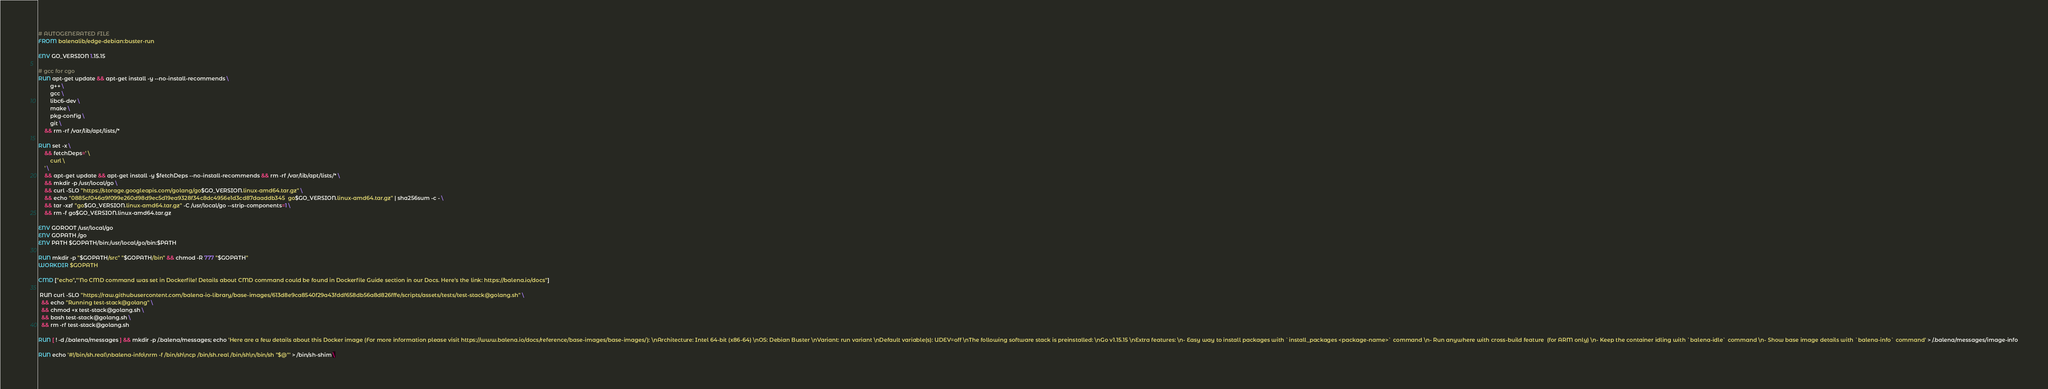<code> <loc_0><loc_0><loc_500><loc_500><_Dockerfile_># AUTOGENERATED FILE
FROM balenalib/edge-debian:buster-run

ENV GO_VERSION 1.15.15

# gcc for cgo
RUN apt-get update && apt-get install -y --no-install-recommends \
		g++ \
		gcc \
		libc6-dev \
		make \
		pkg-config \
		git \
	&& rm -rf /var/lib/apt/lists/*

RUN set -x \
	&& fetchDeps=' \
		curl \
	' \
	&& apt-get update && apt-get install -y $fetchDeps --no-install-recommends && rm -rf /var/lib/apt/lists/* \
	&& mkdir -p /usr/local/go \
	&& curl -SLO "https://storage.googleapis.com/golang/go$GO_VERSION.linux-amd64.tar.gz" \
	&& echo "0885cf046a9f099e260d98d9ec5d19ea9328f34c8dc4956e1d3cd87daaddb345  go$GO_VERSION.linux-amd64.tar.gz" | sha256sum -c - \
	&& tar -xzf "go$GO_VERSION.linux-amd64.tar.gz" -C /usr/local/go --strip-components=1 \
	&& rm -f go$GO_VERSION.linux-amd64.tar.gz

ENV GOROOT /usr/local/go
ENV GOPATH /go
ENV PATH $GOPATH/bin:/usr/local/go/bin:$PATH

RUN mkdir -p "$GOPATH/src" "$GOPATH/bin" && chmod -R 777 "$GOPATH"
WORKDIR $GOPATH

CMD ["echo","'No CMD command was set in Dockerfile! Details about CMD command could be found in Dockerfile Guide section in our Docs. Here's the link: https://balena.io/docs"]

 RUN curl -SLO "https://raw.githubusercontent.com/balena-io-library/base-images/613d8e9ca8540f29a43fddf658db56a8d826fffe/scripts/assets/tests/test-stack@golang.sh" \
  && echo "Running test-stack@golang" \
  && chmod +x test-stack@golang.sh \
  && bash test-stack@golang.sh \
  && rm -rf test-stack@golang.sh 

RUN [ ! -d /.balena/messages ] && mkdir -p /.balena/messages; echo 'Here are a few details about this Docker image (For more information please visit https://www.balena.io/docs/reference/base-images/base-images/): \nArchitecture: Intel 64-bit (x86-64) \nOS: Debian Buster \nVariant: run variant \nDefault variable(s): UDEV=off \nThe following software stack is preinstalled: \nGo v1.15.15 \nExtra features: \n- Easy way to install packages with `install_packages <package-name>` command \n- Run anywhere with cross-build feature  (for ARM only) \n- Keep the container idling with `balena-idle` command \n- Show base image details with `balena-info` command' > /.balena/messages/image-info

RUN echo '#!/bin/sh.real\nbalena-info\nrm -f /bin/sh\ncp /bin/sh.real /bin/sh\n/bin/sh "$@"' > /bin/sh-shim \</code> 